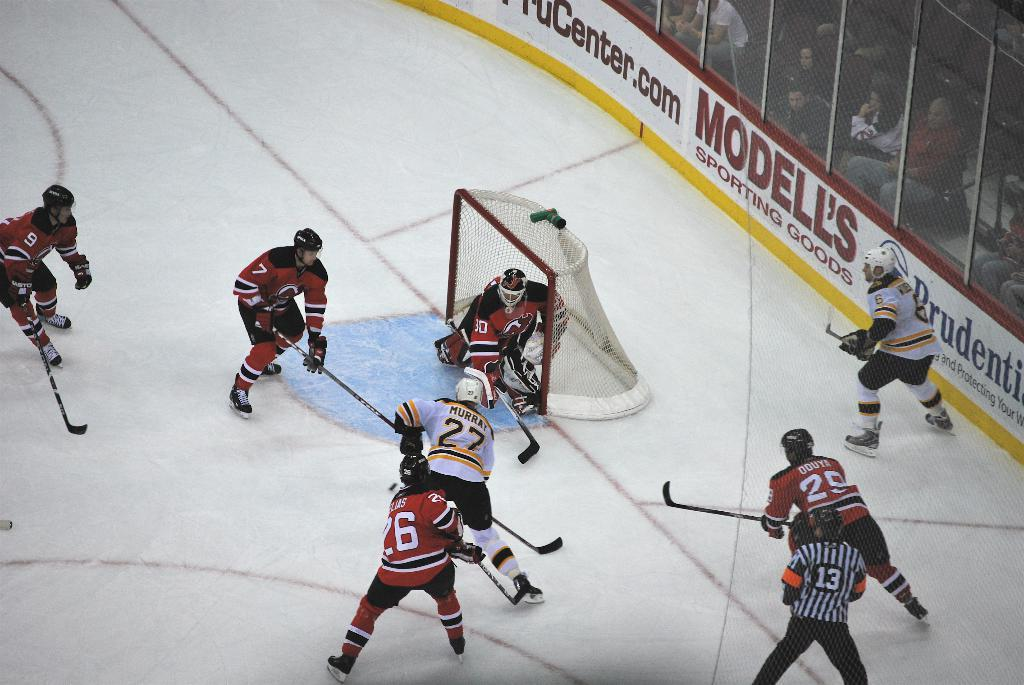<image>
Relay a brief, clear account of the picture shown. An ice hockey game is in progress and one player wears the number 27 shirt. 